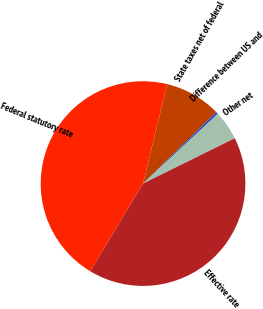Convert chart to OTSL. <chart><loc_0><loc_0><loc_500><loc_500><pie_chart><fcel>Federal statutory rate<fcel>State taxes net of federal<fcel>Difference between US and<fcel>Other net<fcel>Effective rate<nl><fcel>45.18%<fcel>8.9%<fcel>0.37%<fcel>4.63%<fcel>40.92%<nl></chart> 